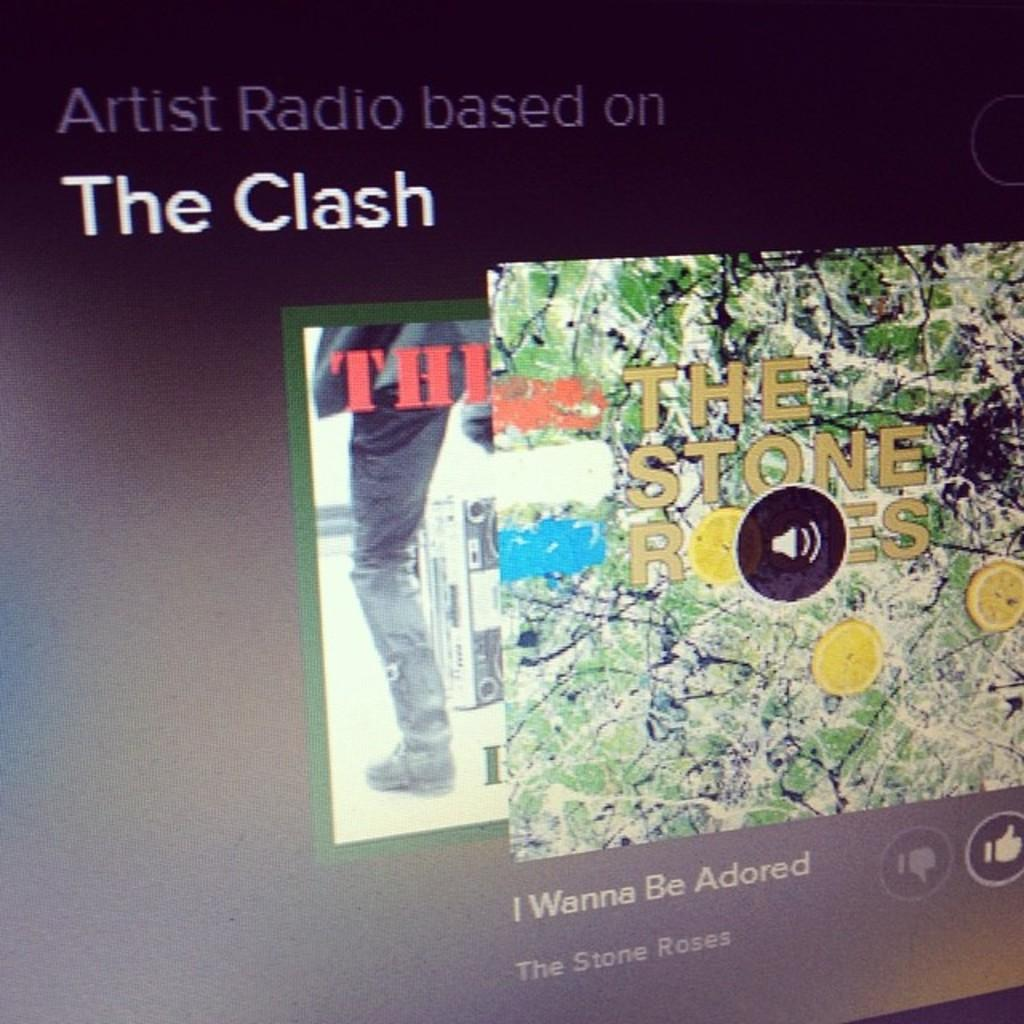<image>
Offer a succinct explanation of the picture presented. The Stone Roses cover art for I Wanna Be Adored is on a computer screen. 